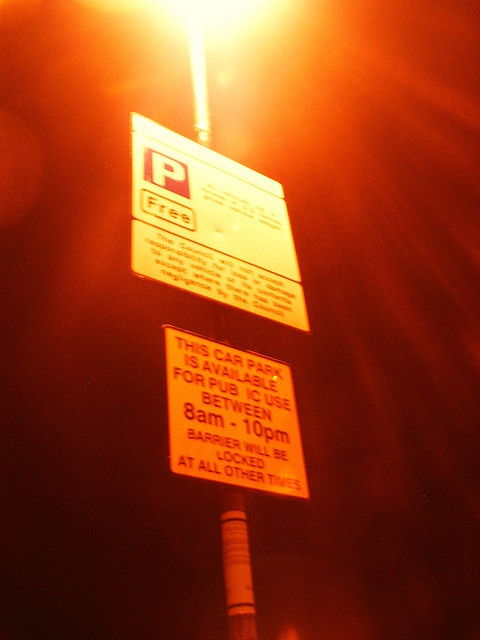Describe the objects in this image and their specific colors. I can see various objects in this image with different colors. 